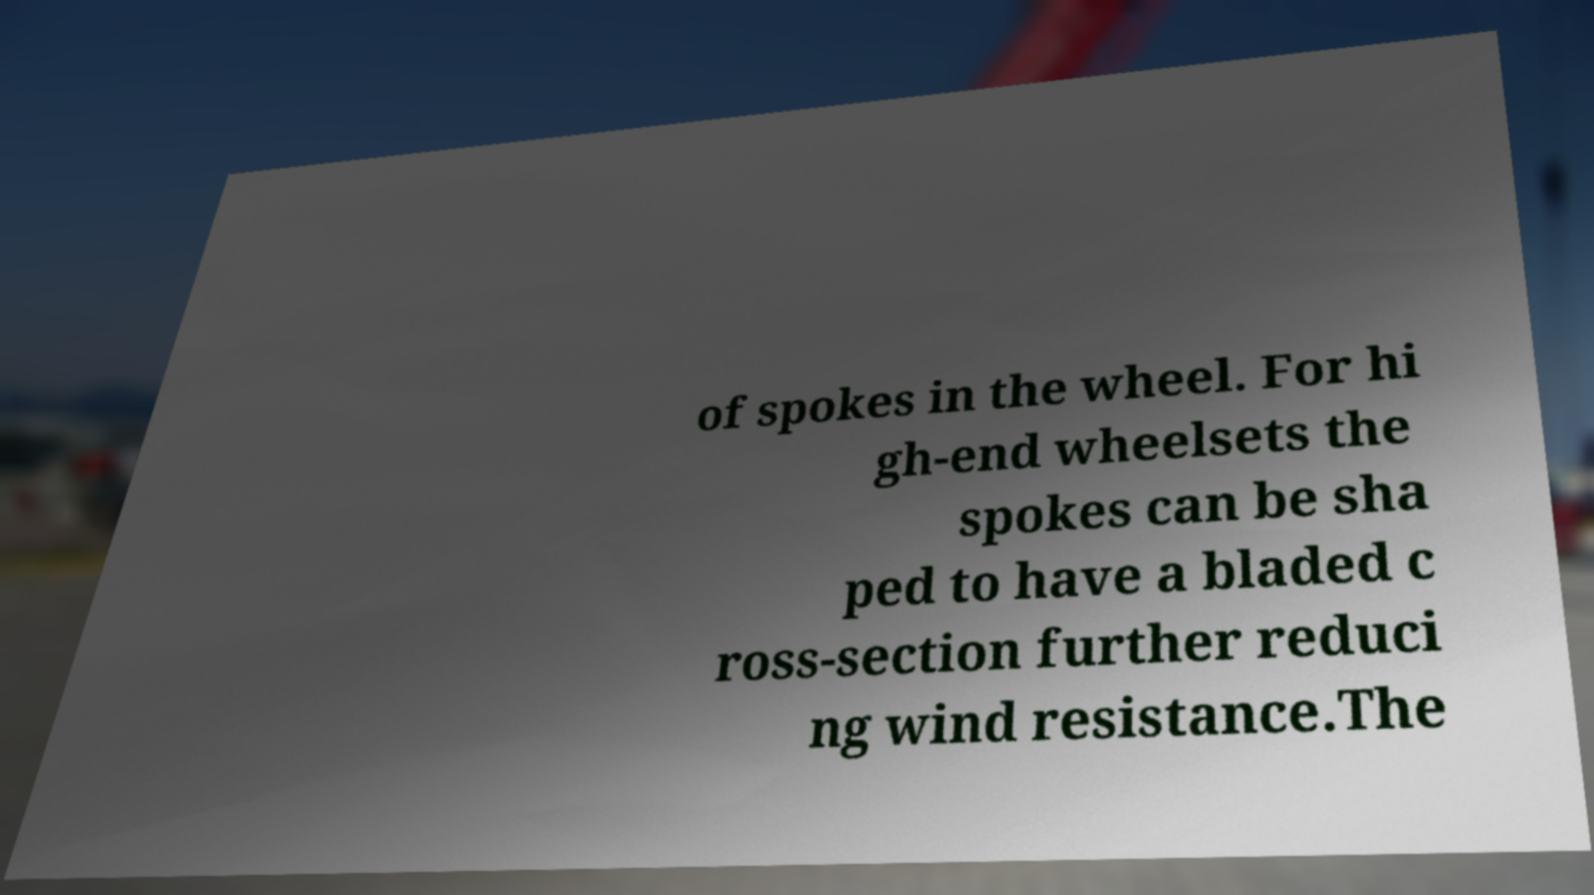Please identify and transcribe the text found in this image. of spokes in the wheel. For hi gh-end wheelsets the spokes can be sha ped to have a bladed c ross-section further reduci ng wind resistance.The 